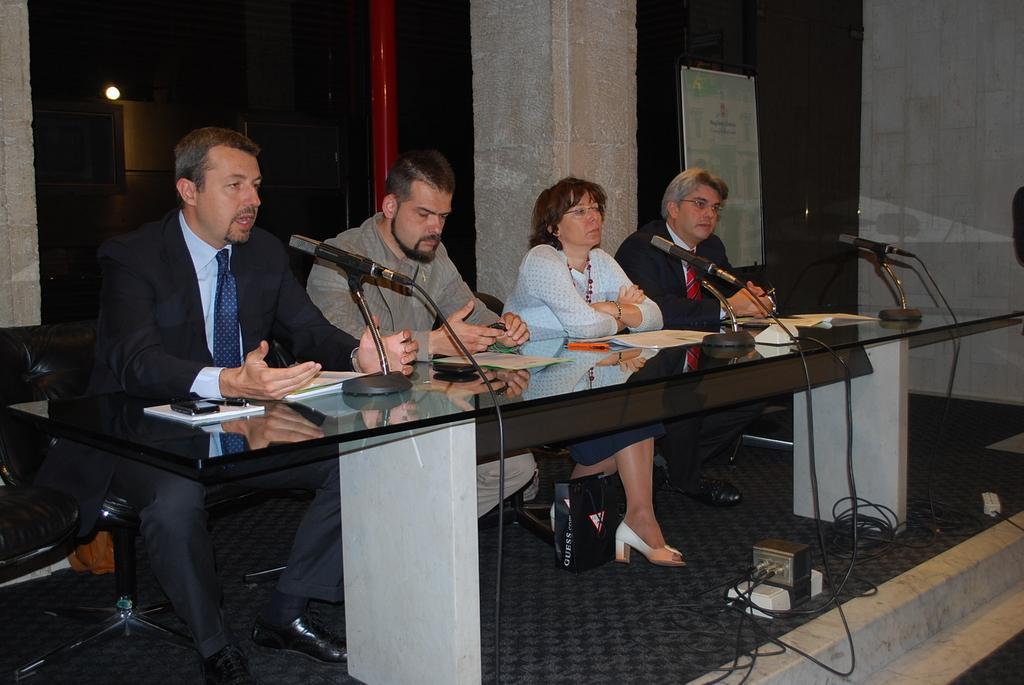In one or two sentences, can you explain what this image depicts? In this image i can see few people sitting on chairs in front of a table, On the table i can see few papers and few microphones. In the background i can see a pillar, a board and a glass wall. 